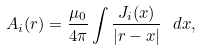Convert formula to latex. <formula><loc_0><loc_0><loc_500><loc_500>A _ { i } ( { r } ) = \frac { \mu _ { 0 } } { 4 \pi } \int \frac { J _ { i } ( { x } ) } { | { r } - { x } | } \ d { x } ,</formula> 